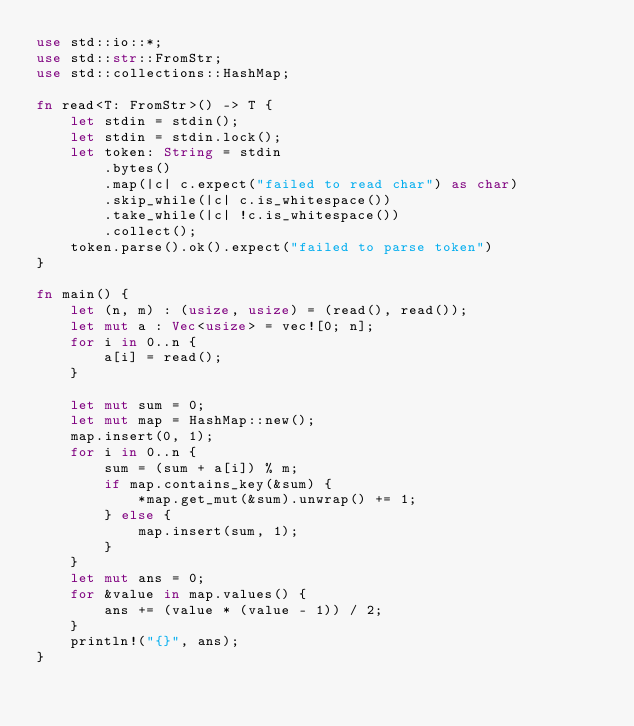Convert code to text. <code><loc_0><loc_0><loc_500><loc_500><_Rust_>use std::io::*;
use std::str::FromStr;
use std::collections::HashMap;

fn read<T: FromStr>() -> T {
    let stdin = stdin();
    let stdin = stdin.lock();
    let token: String = stdin
        .bytes()
        .map(|c| c.expect("failed to read char") as char)
        .skip_while(|c| c.is_whitespace())
        .take_while(|c| !c.is_whitespace())
        .collect();
    token.parse().ok().expect("failed to parse token")
}

fn main() {
    let (n, m) : (usize, usize) = (read(), read());
    let mut a : Vec<usize> = vec![0; n];
    for i in 0..n {
        a[i] = read();
    }

    let mut sum = 0;
    let mut map = HashMap::new();
    map.insert(0, 1);
    for i in 0..n {
        sum = (sum + a[i]) % m;
        if map.contains_key(&sum) {
            *map.get_mut(&sum).unwrap() += 1;
        } else {
            map.insert(sum, 1);
        }
    }
    let mut ans = 0;
    for &value in map.values() {
        ans += (value * (value - 1)) / 2;
    }
    println!("{}", ans);
}
</code> 